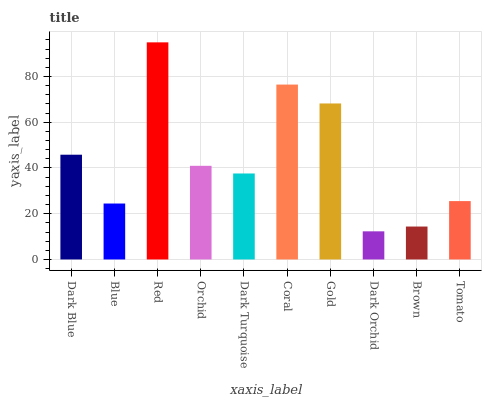Is Dark Orchid the minimum?
Answer yes or no. Yes. Is Red the maximum?
Answer yes or no. Yes. Is Blue the minimum?
Answer yes or no. No. Is Blue the maximum?
Answer yes or no. No. Is Dark Blue greater than Blue?
Answer yes or no. Yes. Is Blue less than Dark Blue?
Answer yes or no. Yes. Is Blue greater than Dark Blue?
Answer yes or no. No. Is Dark Blue less than Blue?
Answer yes or no. No. Is Orchid the high median?
Answer yes or no. Yes. Is Dark Turquoise the low median?
Answer yes or no. Yes. Is Gold the high median?
Answer yes or no. No. Is Gold the low median?
Answer yes or no. No. 